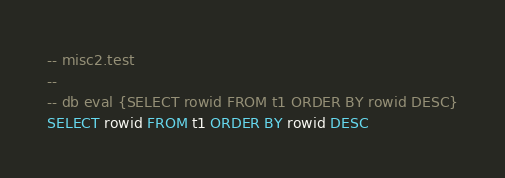Convert code to text. <code><loc_0><loc_0><loc_500><loc_500><_SQL_>-- misc2.test
-- 
-- db eval {SELECT rowid FROM t1 ORDER BY rowid DESC}
SELECT rowid FROM t1 ORDER BY rowid DESC</code> 